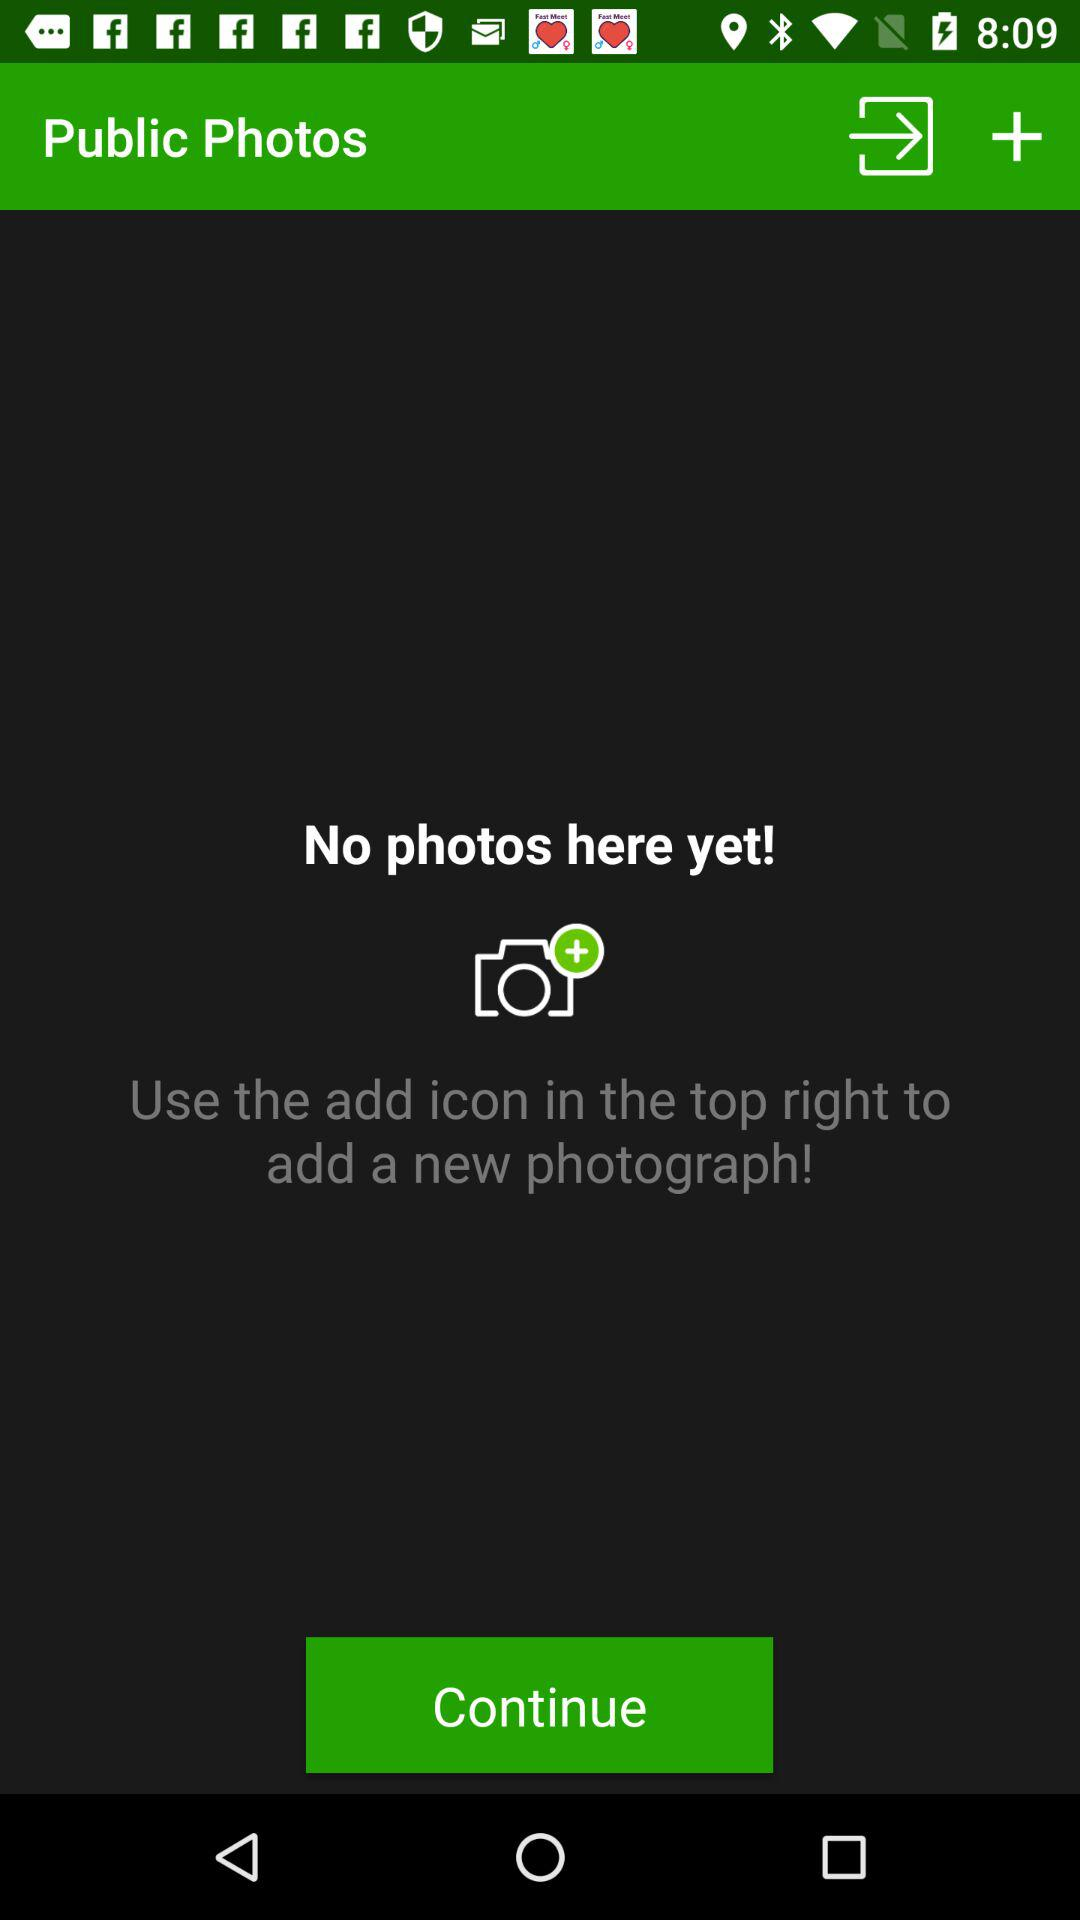How many photos are in the public photos folder?
Answer the question using a single word or phrase. 0 